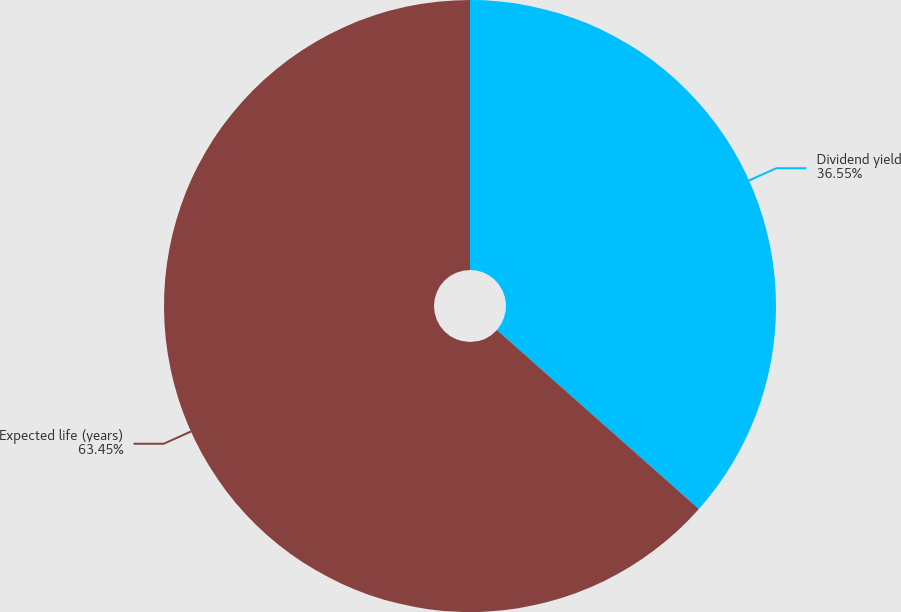Convert chart to OTSL. <chart><loc_0><loc_0><loc_500><loc_500><pie_chart><fcel>Dividend yield<fcel>Expected life (years)<nl><fcel>36.55%<fcel>63.45%<nl></chart> 